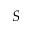Convert formula to latex. <formula><loc_0><loc_0><loc_500><loc_500>S</formula> 